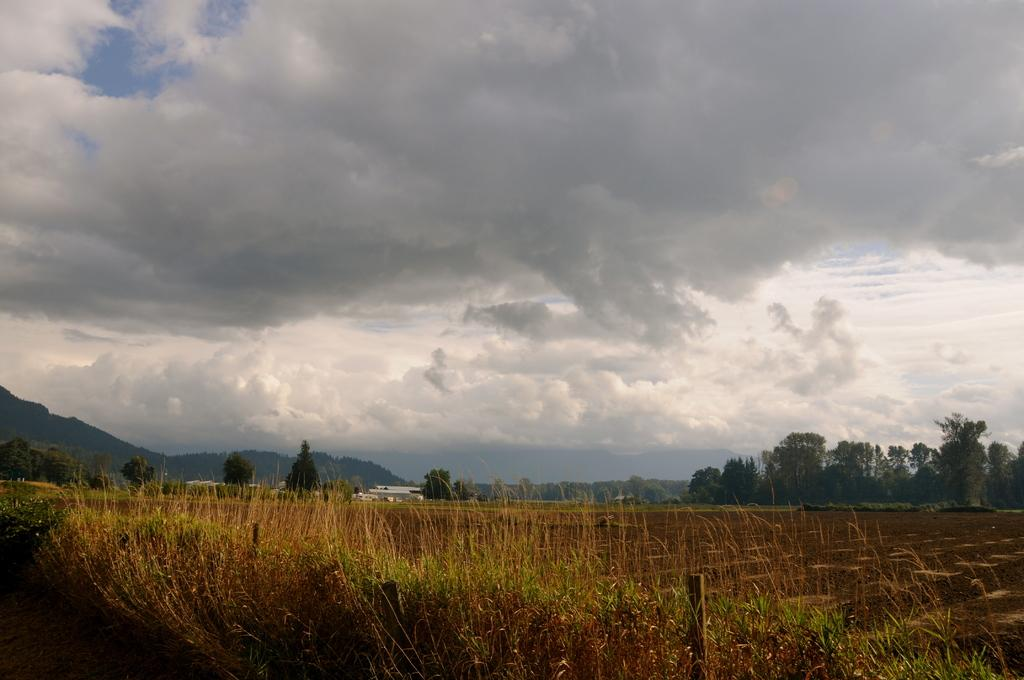What can be seen at the top of the image? There are clouds at the top of the image. What is present at the bottom of the image? There is grass at the bottom of the image. What type of vegetation is visible in the background of the image? There are trees in the background of the image. What is the price of the wood in the image? There is no wood present in the image, so it is not possible to determine its price. 